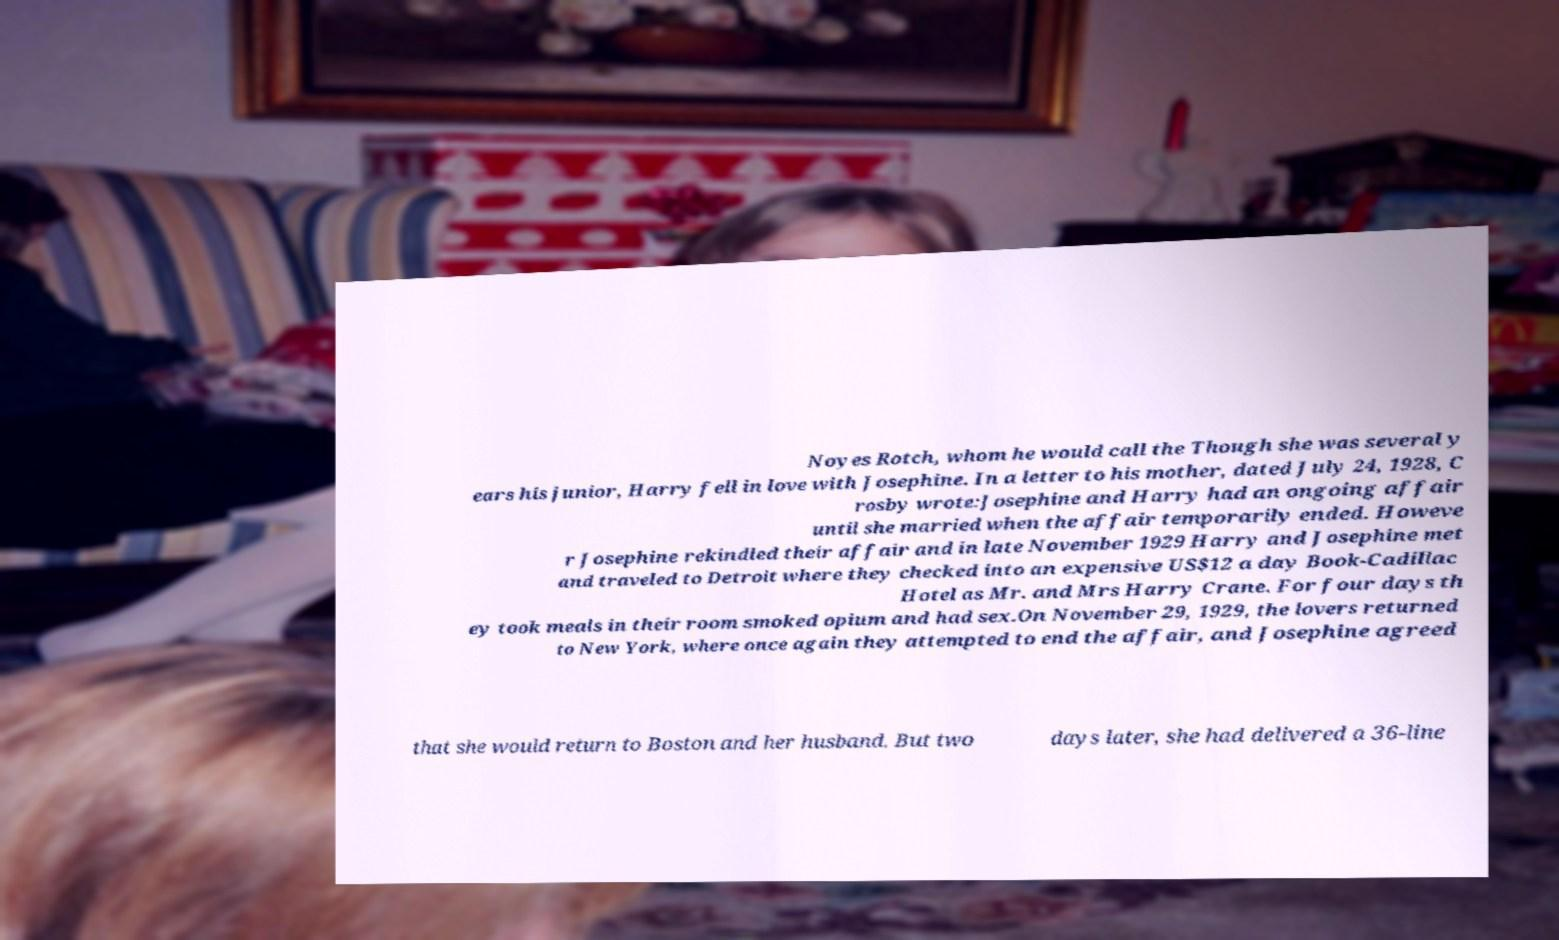There's text embedded in this image that I need extracted. Can you transcribe it verbatim? Noyes Rotch, whom he would call the Though she was several y ears his junior, Harry fell in love with Josephine. In a letter to his mother, dated July 24, 1928, C rosby wrote:Josephine and Harry had an ongoing affair until she married when the affair temporarily ended. Howeve r Josephine rekindled their affair and in late November 1929 Harry and Josephine met and traveled to Detroit where they checked into an expensive US$12 a day Book-Cadillac Hotel as Mr. and Mrs Harry Crane. For four days th ey took meals in their room smoked opium and had sex.On November 29, 1929, the lovers returned to New York, where once again they attempted to end the affair, and Josephine agreed that she would return to Boston and her husband. But two days later, she had delivered a 36-line 